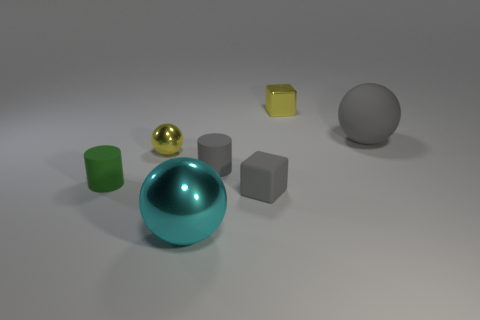Add 3 small gray metal balls. How many objects exist? 10 Subtract all blocks. How many objects are left? 5 Add 5 big metallic things. How many big metallic things exist? 6 Subtract 1 yellow spheres. How many objects are left? 6 Subtract all cyan cubes. Subtract all tiny matte cylinders. How many objects are left? 5 Add 6 gray objects. How many gray objects are left? 9 